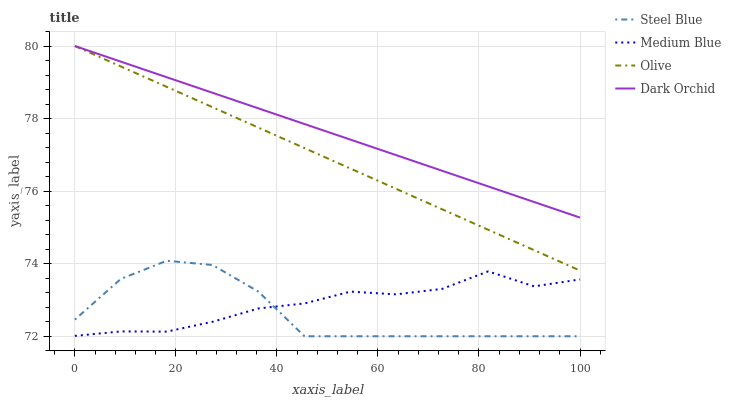Does Steel Blue have the minimum area under the curve?
Answer yes or no. Yes. Does Dark Orchid have the maximum area under the curve?
Answer yes or no. Yes. Does Medium Blue have the minimum area under the curve?
Answer yes or no. No. Does Medium Blue have the maximum area under the curve?
Answer yes or no. No. Is Olive the smoothest?
Answer yes or no. Yes. Is Steel Blue the roughest?
Answer yes or no. Yes. Is Medium Blue the smoothest?
Answer yes or no. No. Is Medium Blue the roughest?
Answer yes or no. No. Does Steel Blue have the lowest value?
Answer yes or no. Yes. Does Medium Blue have the lowest value?
Answer yes or no. No. Does Dark Orchid have the highest value?
Answer yes or no. Yes. Does Steel Blue have the highest value?
Answer yes or no. No. Is Medium Blue less than Olive?
Answer yes or no. Yes. Is Olive greater than Medium Blue?
Answer yes or no. Yes. Does Steel Blue intersect Medium Blue?
Answer yes or no. Yes. Is Steel Blue less than Medium Blue?
Answer yes or no. No. Is Steel Blue greater than Medium Blue?
Answer yes or no. No. Does Medium Blue intersect Olive?
Answer yes or no. No. 